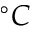Convert formula to latex. <formula><loc_0><loc_0><loc_500><loc_500>^ { \circ } C</formula> 